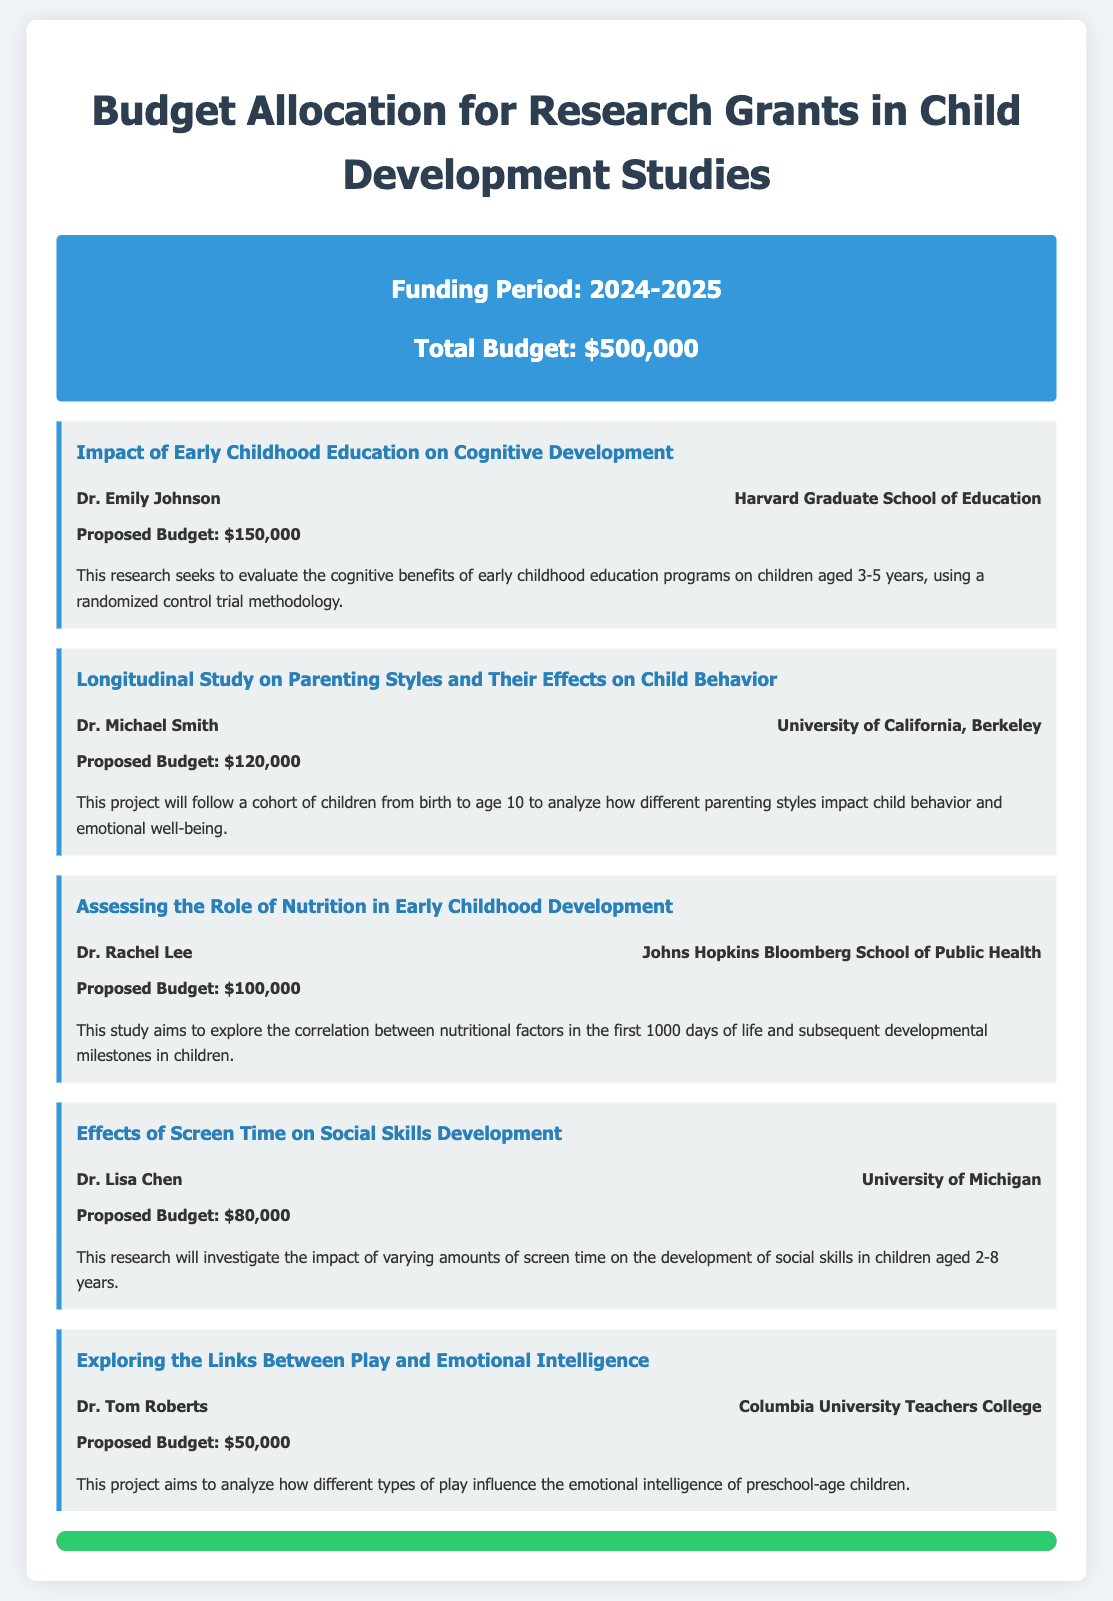What is the total budget for the funding period? The total budget is explicitly stated in the document as $500,000.
Answer: $500,000 Who is the project lead for the "Impact of Early Childhood Education on Cognitive Development"? The project lead's name is given under this project title, which is Dr. Emily Johnson.
Answer: Dr. Emily Johnson What is the proposed budget for the project on nutrition? The proposed budget for the project titled "Assessing the Role of Nutrition in Early Childhood Development" is highlighted in the document as $100,000.
Answer: $100,000 Which institution is associated with Dr. Lisa Chen? The institution associated with Dr. Lisa Chen is mentioned in the project details, which is the University of Michigan.
Answer: University of Michigan How many projects received funding in the budget allocation? The document lists a total of 5 projects under the budget allocation.
Answer: 5 What is the focus of the project led by Dr. Tom Roberts? This project aims to analyze the relationship between play and emotional intelligence in preschool-age children.
Answer: Links Between Play and Emotional Intelligence What percentage of the total budget is requested by the projects? The total funding requested by the listed projects equals the total budget, indicating that it's 100% of the total budget.
Answer: 100% What is the funding period for these research grants? The document specifies the funding period as 2024-2025.
Answer: 2024-2025 What type of research method is used in the project led by Dr. Emily Johnson? The methodology employed in this research is described as a randomized control trial.
Answer: Randomized control trial 